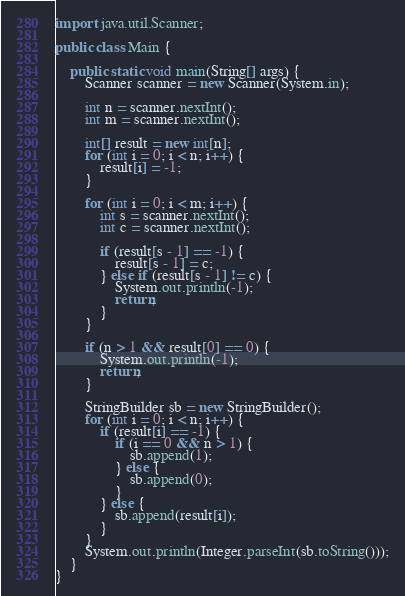Convert code to text. <code><loc_0><loc_0><loc_500><loc_500><_Java_>import java.util.Scanner;

public class Main {

    public static void main(String[] args) {
        Scanner scanner = new Scanner(System.in);

        int n = scanner.nextInt();
        int m = scanner.nextInt();

        int[] result = new int[n];
        for (int i = 0; i < n; i++) {
            result[i] = -1;
        }

        for (int i = 0; i < m; i++) {
            int s = scanner.nextInt();
            int c = scanner.nextInt();

            if (result[s - 1] == -1) {
                result[s - 1] = c;
            } else if (result[s - 1] != c) {
                System.out.println(-1);
                return;
            }
        }

        if (n > 1 && result[0] == 0) {
            System.out.println(-1);
            return;
        }

        StringBuilder sb = new StringBuilder();
        for (int i = 0; i < n; i++) {
            if (result[i] == -1) {
                if (i == 0 && n > 1) {
                    sb.append(1);
                } else {
                    sb.append(0);
                }
            } else {
                sb.append(result[i]);
            }
        }
        System.out.println(Integer.parseInt(sb.toString()));
    }
}
</code> 